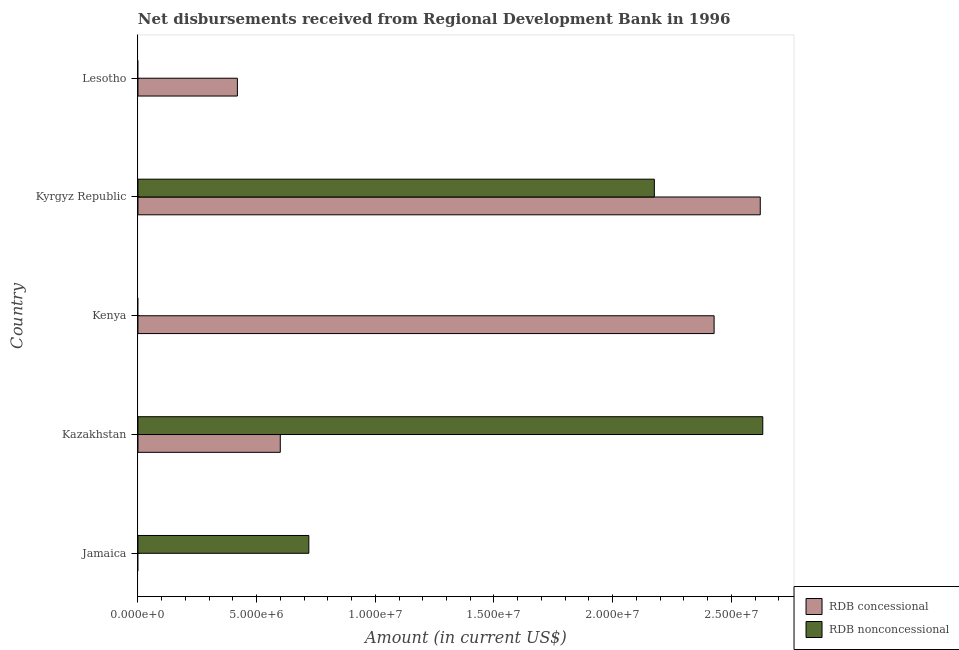How many different coloured bars are there?
Your answer should be very brief. 2. Are the number of bars per tick equal to the number of legend labels?
Offer a terse response. No. How many bars are there on the 2nd tick from the top?
Offer a terse response. 2. How many bars are there on the 5th tick from the bottom?
Provide a short and direct response. 1. What is the label of the 2nd group of bars from the top?
Make the answer very short. Kyrgyz Republic. What is the net non concessional disbursements from rdb in Jamaica?
Provide a short and direct response. 7.20e+06. Across all countries, what is the maximum net non concessional disbursements from rdb?
Provide a short and direct response. 2.63e+07. In which country was the net non concessional disbursements from rdb maximum?
Offer a terse response. Kazakhstan. What is the total net concessional disbursements from rdb in the graph?
Your answer should be very brief. 6.07e+07. What is the difference between the net non concessional disbursements from rdb in Jamaica and that in Kyrgyz Republic?
Keep it short and to the point. -1.46e+07. What is the difference between the net non concessional disbursements from rdb in Kyrgyz Republic and the net concessional disbursements from rdb in Lesotho?
Your answer should be compact. 1.76e+07. What is the average net concessional disbursements from rdb per country?
Your answer should be compact. 1.21e+07. What is the difference between the net concessional disbursements from rdb and net non concessional disbursements from rdb in Kyrgyz Republic?
Offer a terse response. 4.46e+06. What is the ratio of the net non concessional disbursements from rdb in Kazakhstan to that in Kyrgyz Republic?
Your answer should be very brief. 1.21. What is the difference between the highest and the second highest net non concessional disbursements from rdb?
Provide a short and direct response. 4.57e+06. What is the difference between the highest and the lowest net concessional disbursements from rdb?
Your response must be concise. 2.62e+07. What is the difference between two consecutive major ticks on the X-axis?
Your answer should be very brief. 5.00e+06. Where does the legend appear in the graph?
Ensure brevity in your answer.  Bottom right. How many legend labels are there?
Offer a very short reply. 2. How are the legend labels stacked?
Your answer should be compact. Vertical. What is the title of the graph?
Offer a terse response. Net disbursements received from Regional Development Bank in 1996. Does "Fertility rate" appear as one of the legend labels in the graph?
Provide a short and direct response. No. What is the label or title of the X-axis?
Ensure brevity in your answer.  Amount (in current US$). What is the label or title of the Y-axis?
Offer a very short reply. Country. What is the Amount (in current US$) in RDB nonconcessional in Jamaica?
Your answer should be very brief. 7.20e+06. What is the Amount (in current US$) of RDB concessional in Kazakhstan?
Offer a terse response. 6.00e+06. What is the Amount (in current US$) of RDB nonconcessional in Kazakhstan?
Give a very brief answer. 2.63e+07. What is the Amount (in current US$) of RDB concessional in Kenya?
Offer a very short reply. 2.43e+07. What is the Amount (in current US$) in RDB concessional in Kyrgyz Republic?
Provide a short and direct response. 2.62e+07. What is the Amount (in current US$) of RDB nonconcessional in Kyrgyz Republic?
Provide a short and direct response. 2.18e+07. What is the Amount (in current US$) of RDB concessional in Lesotho?
Offer a terse response. 4.19e+06. What is the Amount (in current US$) of RDB nonconcessional in Lesotho?
Your response must be concise. 0. Across all countries, what is the maximum Amount (in current US$) of RDB concessional?
Give a very brief answer. 2.62e+07. Across all countries, what is the maximum Amount (in current US$) in RDB nonconcessional?
Your answer should be compact. 2.63e+07. Across all countries, what is the minimum Amount (in current US$) in RDB concessional?
Your response must be concise. 0. Across all countries, what is the minimum Amount (in current US$) of RDB nonconcessional?
Make the answer very short. 0. What is the total Amount (in current US$) of RDB concessional in the graph?
Ensure brevity in your answer.  6.07e+07. What is the total Amount (in current US$) of RDB nonconcessional in the graph?
Your answer should be compact. 5.53e+07. What is the difference between the Amount (in current US$) in RDB nonconcessional in Jamaica and that in Kazakhstan?
Your response must be concise. -1.91e+07. What is the difference between the Amount (in current US$) of RDB nonconcessional in Jamaica and that in Kyrgyz Republic?
Offer a terse response. -1.46e+07. What is the difference between the Amount (in current US$) of RDB concessional in Kazakhstan and that in Kenya?
Keep it short and to the point. -1.83e+07. What is the difference between the Amount (in current US$) in RDB concessional in Kazakhstan and that in Kyrgyz Republic?
Offer a very short reply. -2.02e+07. What is the difference between the Amount (in current US$) in RDB nonconcessional in Kazakhstan and that in Kyrgyz Republic?
Keep it short and to the point. 4.57e+06. What is the difference between the Amount (in current US$) in RDB concessional in Kazakhstan and that in Lesotho?
Give a very brief answer. 1.81e+06. What is the difference between the Amount (in current US$) in RDB concessional in Kenya and that in Kyrgyz Republic?
Your answer should be compact. -1.94e+06. What is the difference between the Amount (in current US$) of RDB concessional in Kenya and that in Lesotho?
Give a very brief answer. 2.01e+07. What is the difference between the Amount (in current US$) of RDB concessional in Kyrgyz Republic and that in Lesotho?
Offer a terse response. 2.20e+07. What is the difference between the Amount (in current US$) in RDB concessional in Kazakhstan and the Amount (in current US$) in RDB nonconcessional in Kyrgyz Republic?
Keep it short and to the point. -1.58e+07. What is the difference between the Amount (in current US$) of RDB concessional in Kenya and the Amount (in current US$) of RDB nonconcessional in Kyrgyz Republic?
Give a very brief answer. 2.52e+06. What is the average Amount (in current US$) of RDB concessional per country?
Offer a very short reply. 1.21e+07. What is the average Amount (in current US$) in RDB nonconcessional per country?
Offer a very short reply. 1.11e+07. What is the difference between the Amount (in current US$) of RDB concessional and Amount (in current US$) of RDB nonconcessional in Kazakhstan?
Your answer should be very brief. -2.03e+07. What is the difference between the Amount (in current US$) in RDB concessional and Amount (in current US$) in RDB nonconcessional in Kyrgyz Republic?
Offer a terse response. 4.46e+06. What is the ratio of the Amount (in current US$) of RDB nonconcessional in Jamaica to that in Kazakhstan?
Offer a terse response. 0.27. What is the ratio of the Amount (in current US$) of RDB nonconcessional in Jamaica to that in Kyrgyz Republic?
Keep it short and to the point. 0.33. What is the ratio of the Amount (in current US$) of RDB concessional in Kazakhstan to that in Kenya?
Offer a very short reply. 0.25. What is the ratio of the Amount (in current US$) in RDB concessional in Kazakhstan to that in Kyrgyz Republic?
Give a very brief answer. 0.23. What is the ratio of the Amount (in current US$) in RDB nonconcessional in Kazakhstan to that in Kyrgyz Republic?
Your response must be concise. 1.21. What is the ratio of the Amount (in current US$) of RDB concessional in Kazakhstan to that in Lesotho?
Your answer should be compact. 1.43. What is the ratio of the Amount (in current US$) of RDB concessional in Kenya to that in Kyrgyz Republic?
Give a very brief answer. 0.93. What is the ratio of the Amount (in current US$) of RDB concessional in Kenya to that in Lesotho?
Keep it short and to the point. 5.79. What is the ratio of the Amount (in current US$) of RDB concessional in Kyrgyz Republic to that in Lesotho?
Offer a terse response. 6.26. What is the difference between the highest and the second highest Amount (in current US$) of RDB concessional?
Provide a succinct answer. 1.94e+06. What is the difference between the highest and the second highest Amount (in current US$) of RDB nonconcessional?
Ensure brevity in your answer.  4.57e+06. What is the difference between the highest and the lowest Amount (in current US$) of RDB concessional?
Give a very brief answer. 2.62e+07. What is the difference between the highest and the lowest Amount (in current US$) in RDB nonconcessional?
Keep it short and to the point. 2.63e+07. 